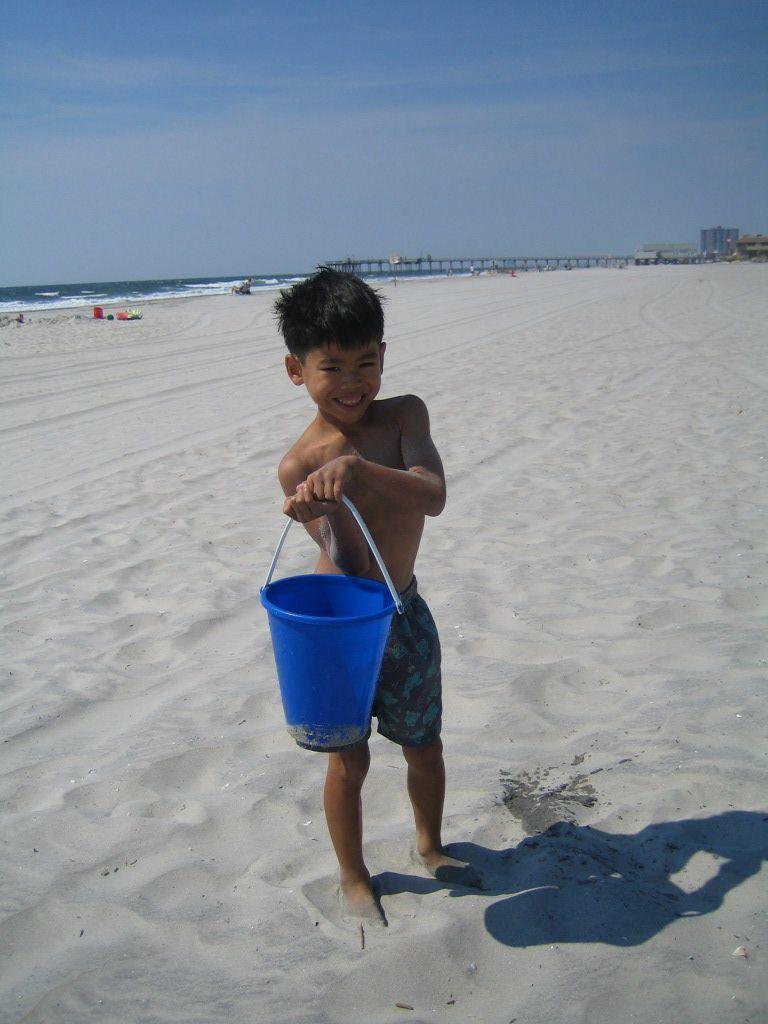Please provide a concise description of this image. In this image there is a child holding a bucket and standing on the sand, a bridge, buildings, a sea, few objects in the sand and the sky. 